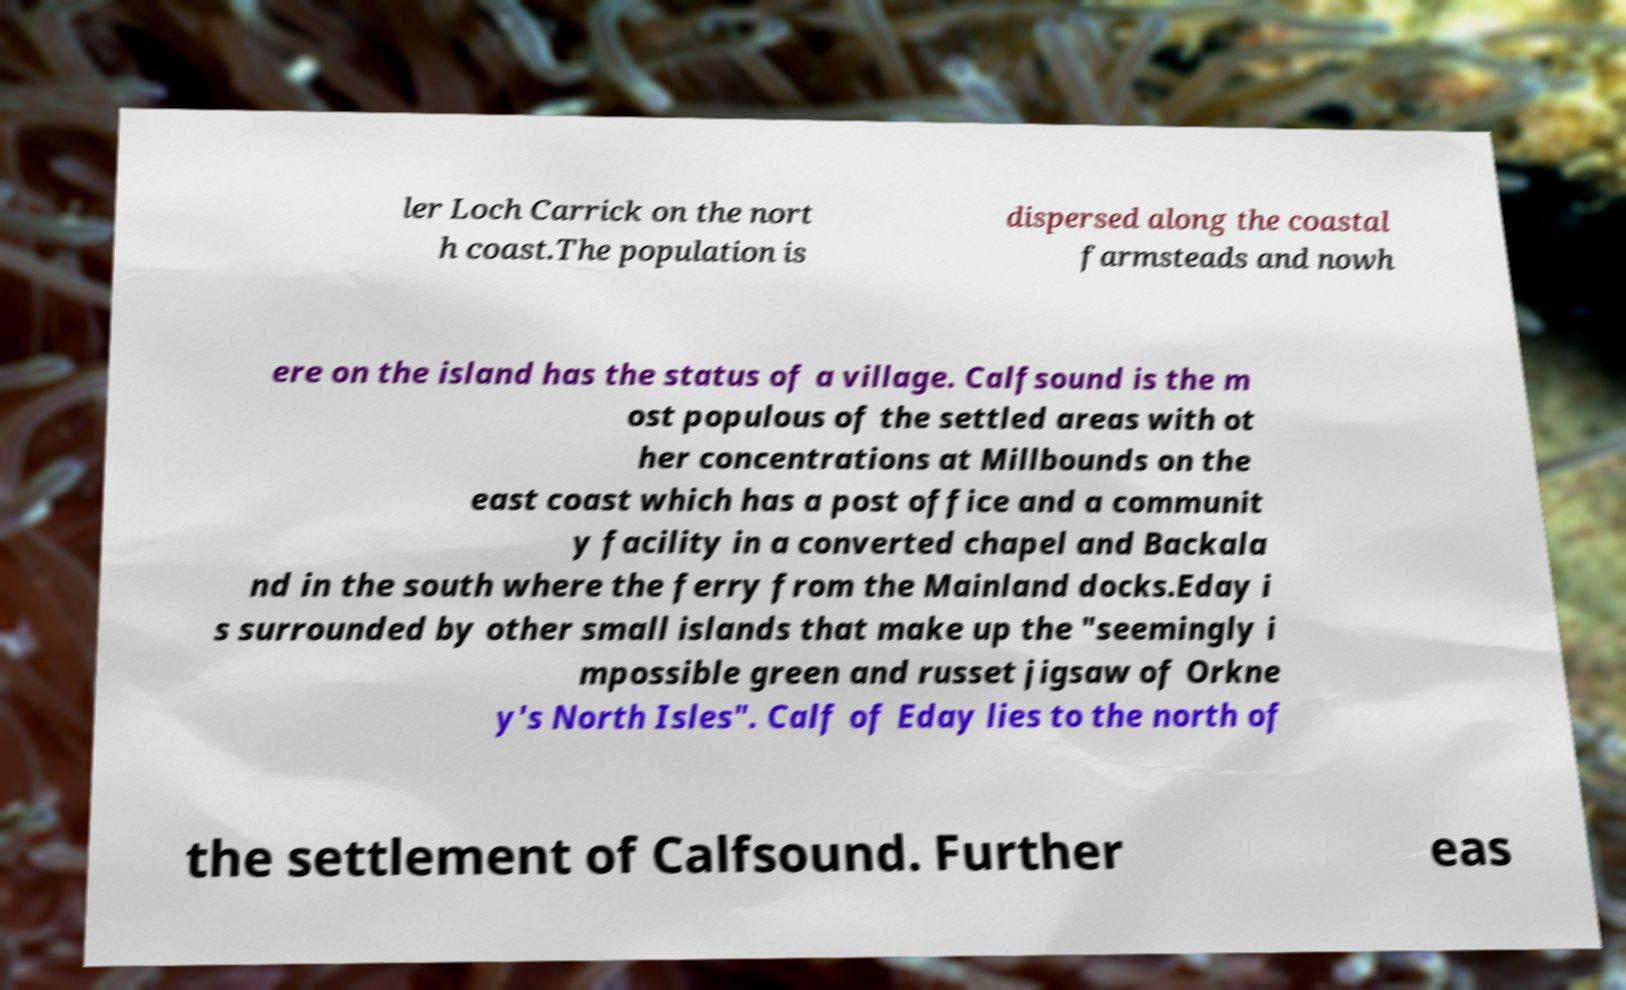Can you accurately transcribe the text from the provided image for me? ler Loch Carrick on the nort h coast.The population is dispersed along the coastal farmsteads and nowh ere on the island has the status of a village. Calfsound is the m ost populous of the settled areas with ot her concentrations at Millbounds on the east coast which has a post office and a communit y facility in a converted chapel and Backala nd in the south where the ferry from the Mainland docks.Eday i s surrounded by other small islands that make up the "seemingly i mpossible green and russet jigsaw of Orkne y's North Isles". Calf of Eday lies to the north of the settlement of Calfsound. Further eas 